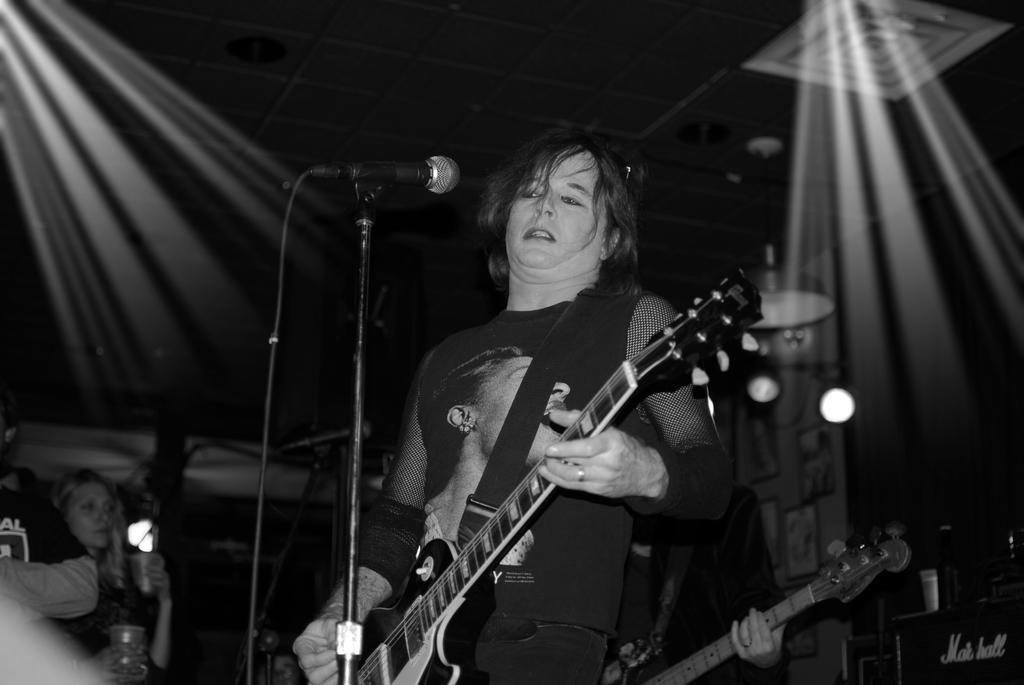How would you summarize this image in a sentence or two? This is a black and white picture. There are two people standing and playing guitar. This is the mic attached to the mike stand. At the left corner of the image I can see two people standing. These are the show lights. I can see a black color object with bottle,glass placed on it. 